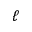Convert formula to latex. <formula><loc_0><loc_0><loc_500><loc_500>\ell</formula> 